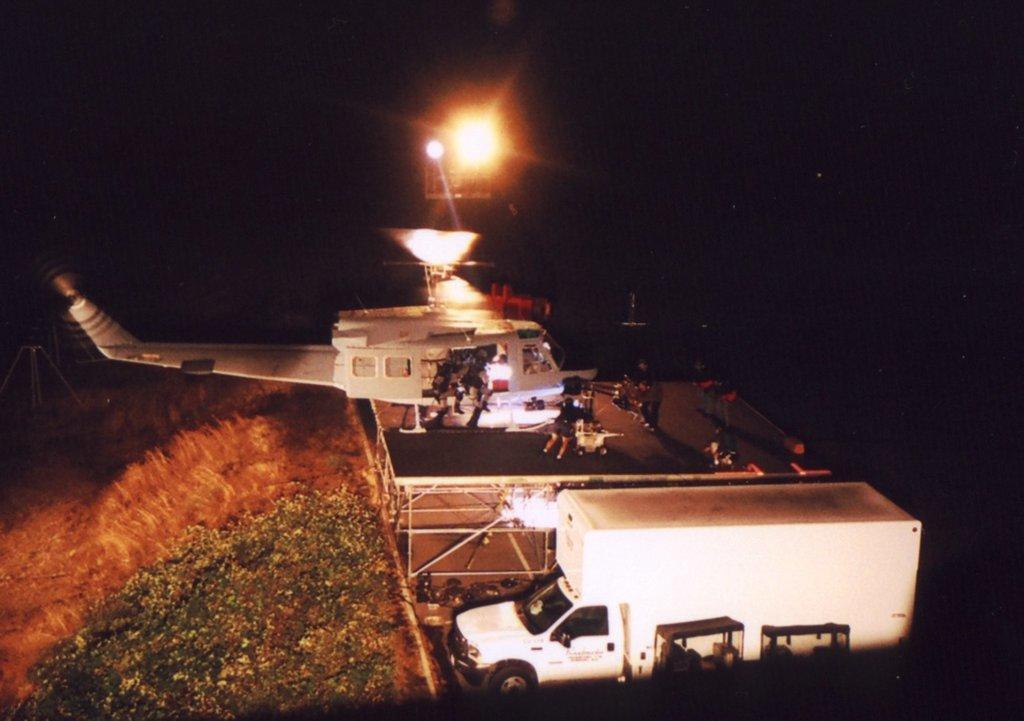Describe this image in one or two sentences. At the bottom of the image there is a vehicle. Behind the vehicle there's a roof with many people on it. And there is a helicopter. Inside the helicopter there are few people. And there is a dark background. Above the helicopter there is a light. 